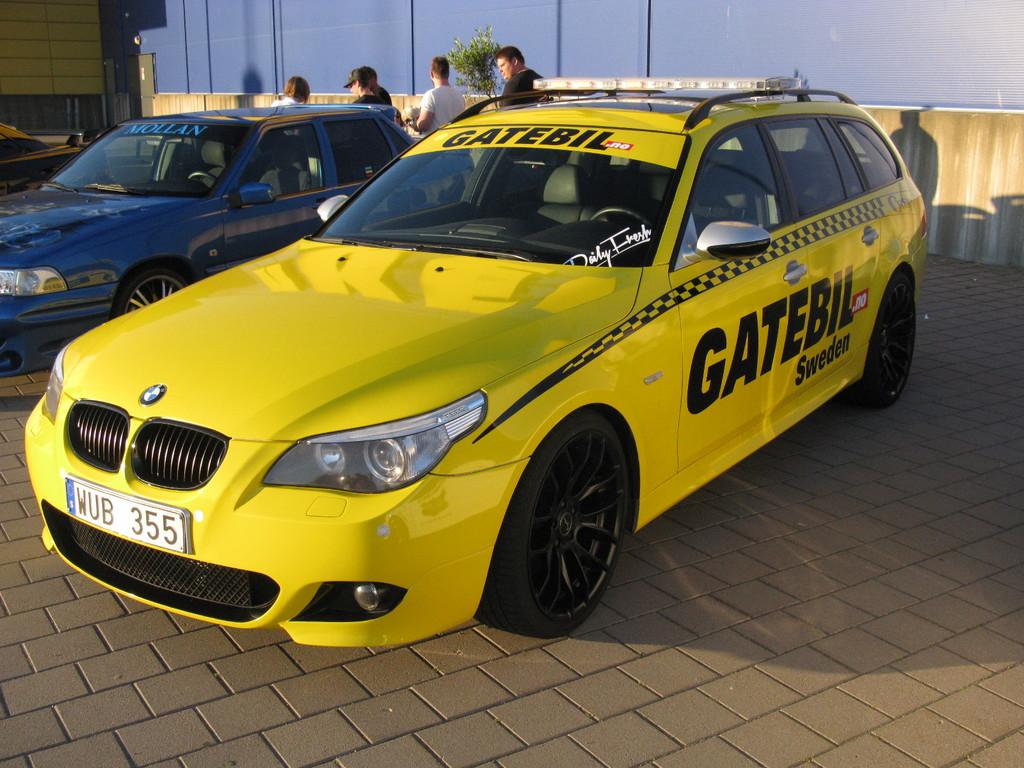What type of car is that?
Your answer should be very brief. Answering does not require reading text in the image. This car is a bmw?
Give a very brief answer. Yes. 